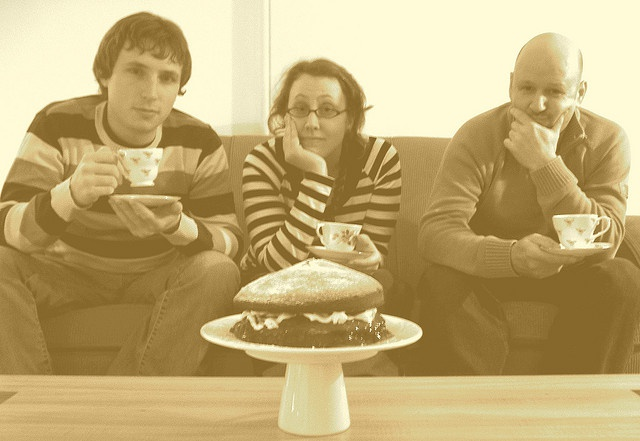Describe the objects in this image and their specific colors. I can see people in beige, olive, and tan tones, dining table in beige, khaki, tan, and olive tones, people in beige, olive, tan, and khaki tones, people in beige, olive, tan, and khaki tones, and couch in beige, olive, and tan tones in this image. 